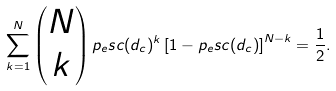Convert formula to latex. <formula><loc_0><loc_0><loc_500><loc_500>\sum _ { k = 1 } ^ { N } \begin{pmatrix} N \\ k \end{pmatrix} p _ { e } s c ( d _ { c } ) ^ { k } \left [ 1 - p _ { e } s c ( d _ { c } ) \right ] ^ { N - k } = \frac { 1 } { 2 } .</formula> 